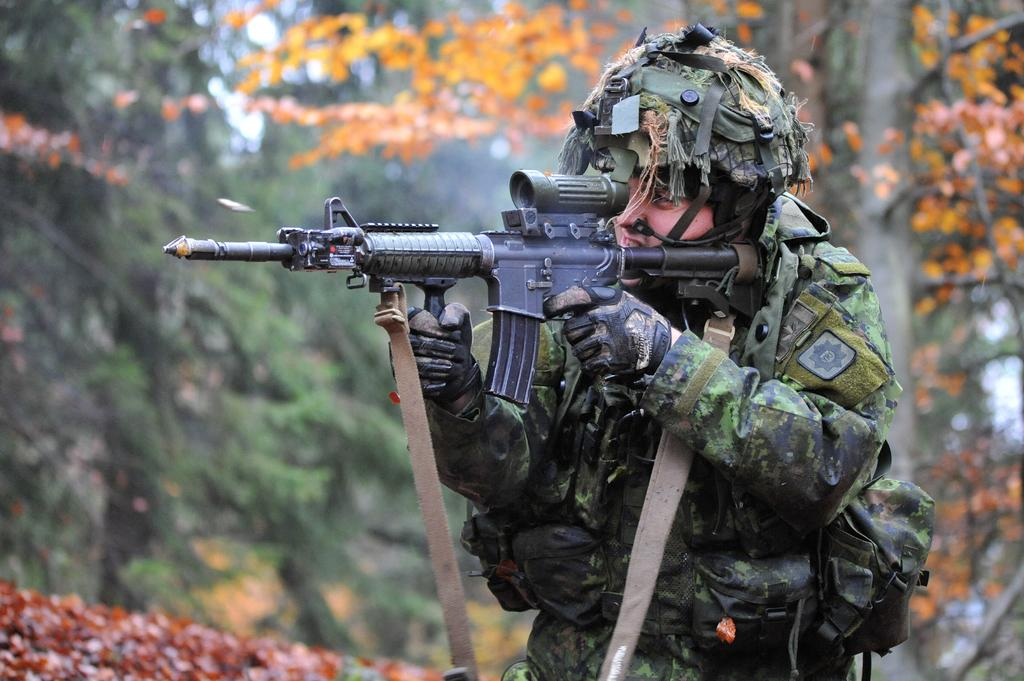What is the main subject of the picture? The main subject of the picture is a soldier. What is the soldier holding in the picture? The soldier is holding a weapon. Can you describe the background of the soldier? The background of the soldier is blurred. What type of silver object can be seen in the soldier's hand in the image? There is no silver object present in the soldier's hand in the image. Is the soldier in a prison or a church in the image? The image does not show the soldier in a prison or a church; it only shows the soldier holding a weapon with a blurred background. 